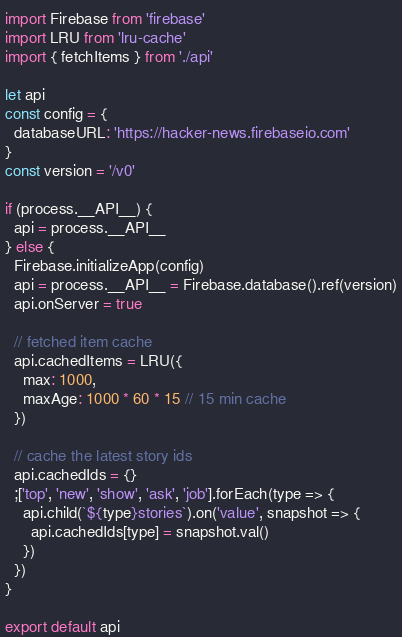<code> <loc_0><loc_0><loc_500><loc_500><_JavaScript_>import Firebase from 'firebase'
import LRU from 'lru-cache'
import { fetchItems } from './api'

let api
const config = {
  databaseURL: 'https://hacker-news.firebaseio.com'
}
const version = '/v0'

if (process.__API__) {
  api = process.__API__
} else {
  Firebase.initializeApp(config)
  api = process.__API__ = Firebase.database().ref(version)
  api.onServer = true

  // fetched item cache
  api.cachedItems = LRU({
    max: 1000,
    maxAge: 1000 * 60 * 15 // 15 min cache
  })

  // cache the latest story ids
  api.cachedIds = {}
  ;['top', 'new', 'show', 'ask', 'job'].forEach(type => {
    api.child(`${type}stories`).on('value', snapshot => {
      api.cachedIds[type] = snapshot.val()
    })
  })
}

export default api
</code> 